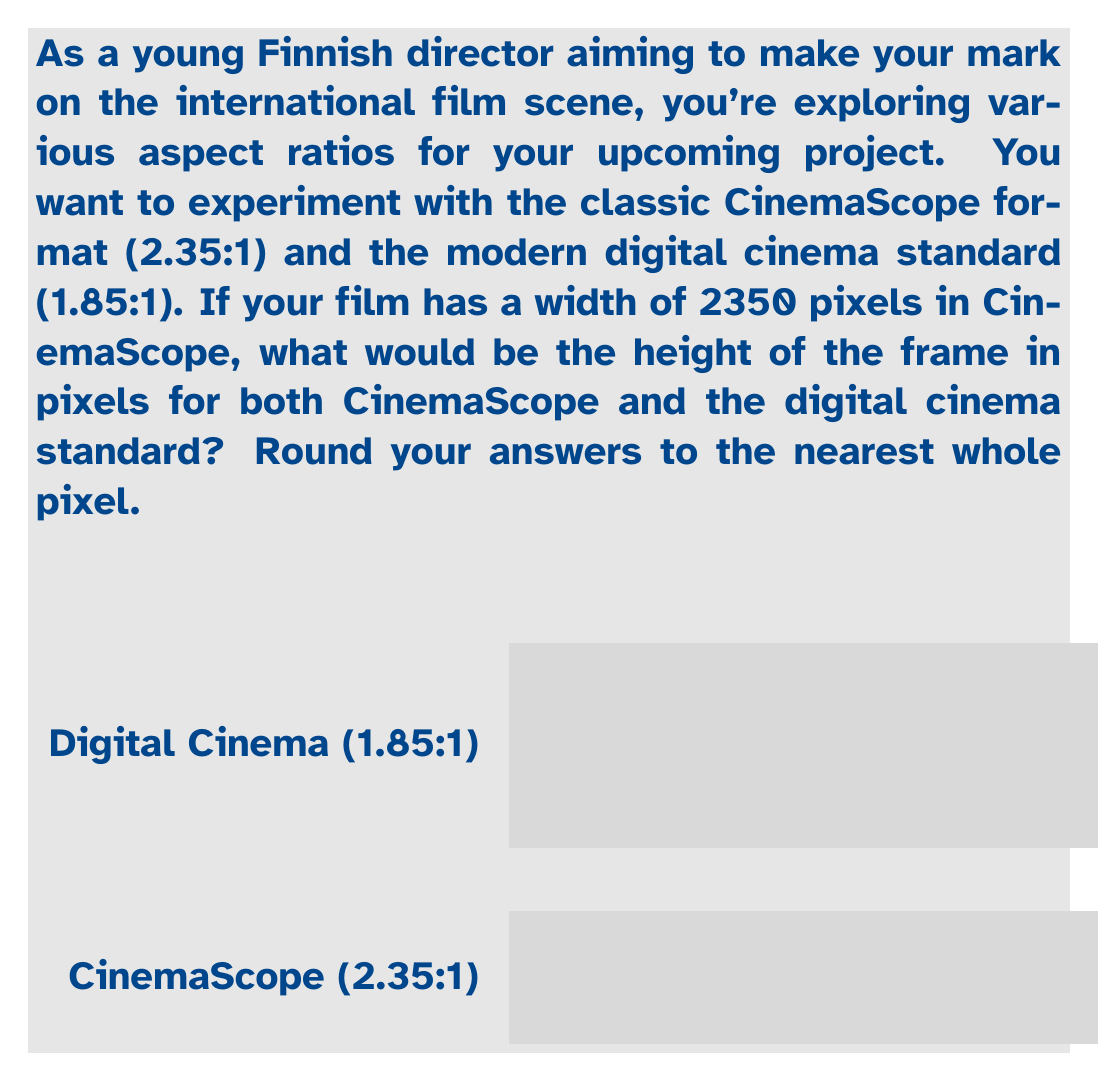Solve this math problem. Let's approach this step-by-step:

1) For CinemaScope (2.35:1):
   - We know the width is 2350 pixels
   - The aspect ratio is 2.35:1, which means width:height = 2.35:1
   - We can set up the equation: $\frac{2350}{h} = 2.35$, where h is the height
   - Solving for h: $h = \frac{2350}{2.35} = 1000$ pixels

2) For Digital Cinema Standard (1.85:1):
   - We still use the same width of 2350 pixels
   - The aspect ratio is 1.85:1
   - We set up a similar equation: $\frac{2350}{h} = 1.85$
   - Solving for h: $h = \frac{2350}{1.85} = 1270.27$ pixels
   - Rounding to the nearest whole pixel: 1270 pixels

Therefore, for a width of 2350 pixels:
- CinemaScope (2.35:1) height: 1000 pixels
- Digital Cinema (1.85:1) height: 1270 pixels
Answer: CinemaScope: 1000 pixels; Digital Cinema: 1270 pixels 